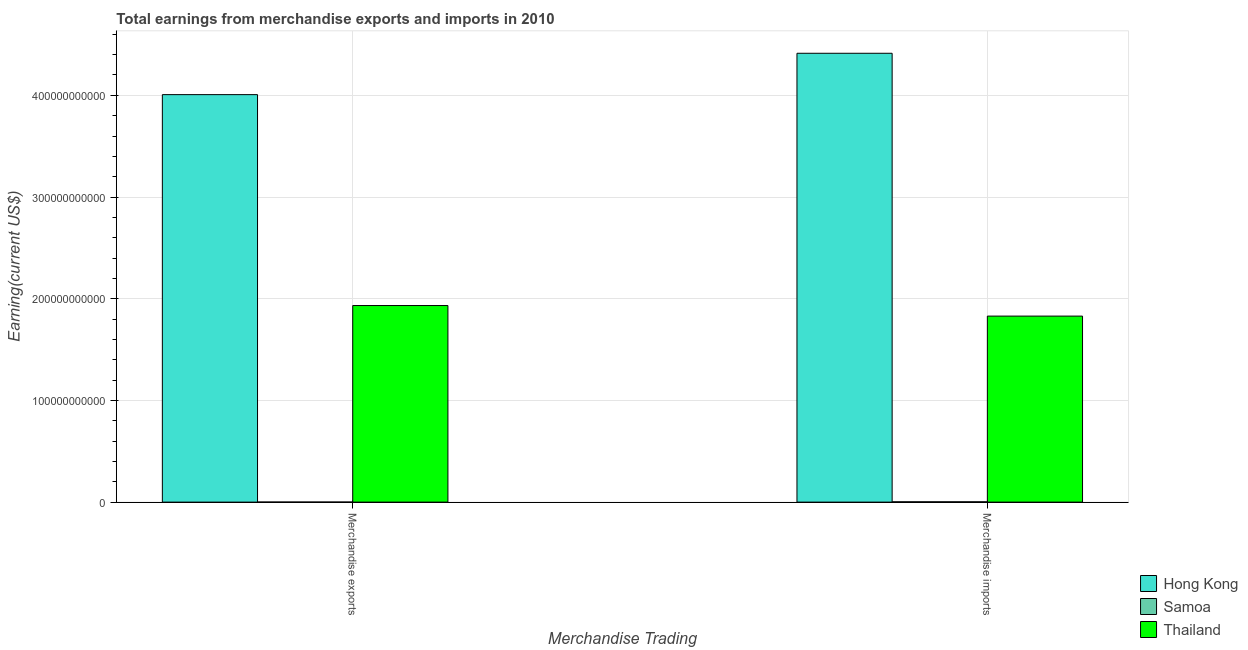Are the number of bars per tick equal to the number of legend labels?
Offer a terse response. Yes. How many bars are there on the 1st tick from the left?
Ensure brevity in your answer.  3. What is the label of the 1st group of bars from the left?
Offer a terse response. Merchandise exports. What is the earnings from merchandise exports in Thailand?
Keep it short and to the point. 1.93e+11. Across all countries, what is the maximum earnings from merchandise imports?
Your answer should be very brief. 4.41e+11. Across all countries, what is the minimum earnings from merchandise imports?
Ensure brevity in your answer.  3.10e+08. In which country was the earnings from merchandise imports maximum?
Your answer should be very brief. Hong Kong. In which country was the earnings from merchandise imports minimum?
Keep it short and to the point. Samoa. What is the total earnings from merchandise exports in the graph?
Keep it short and to the point. 5.94e+11. What is the difference between the earnings from merchandise imports in Thailand and that in Samoa?
Your response must be concise. 1.83e+11. What is the difference between the earnings from merchandise exports in Thailand and the earnings from merchandise imports in Hong Kong?
Ensure brevity in your answer.  -2.48e+11. What is the average earnings from merchandise exports per country?
Ensure brevity in your answer.  1.98e+11. What is the difference between the earnings from merchandise imports and earnings from merchandise exports in Thailand?
Keep it short and to the point. -1.04e+1. In how many countries, is the earnings from merchandise imports greater than 280000000000 US$?
Your response must be concise. 1. What is the ratio of the earnings from merchandise imports in Samoa to that in Hong Kong?
Offer a terse response. 0. In how many countries, is the earnings from merchandise imports greater than the average earnings from merchandise imports taken over all countries?
Your answer should be compact. 1. What does the 1st bar from the left in Merchandise imports represents?
Ensure brevity in your answer.  Hong Kong. What does the 2nd bar from the right in Merchandise imports represents?
Keep it short and to the point. Samoa. How many bars are there?
Provide a short and direct response. 6. Are all the bars in the graph horizontal?
Your response must be concise. No. What is the difference between two consecutive major ticks on the Y-axis?
Your answer should be very brief. 1.00e+11. How many legend labels are there?
Ensure brevity in your answer.  3. What is the title of the graph?
Give a very brief answer. Total earnings from merchandise exports and imports in 2010. Does "Guam" appear as one of the legend labels in the graph?
Provide a succinct answer. No. What is the label or title of the X-axis?
Ensure brevity in your answer.  Merchandise Trading. What is the label or title of the Y-axis?
Ensure brevity in your answer.  Earning(current US$). What is the Earning(current US$) in Hong Kong in Merchandise exports?
Your response must be concise. 4.01e+11. What is the Earning(current US$) in Samoa in Merchandise exports?
Make the answer very short. 7.02e+07. What is the Earning(current US$) in Thailand in Merchandise exports?
Your answer should be compact. 1.93e+11. What is the Earning(current US$) of Hong Kong in Merchandise imports?
Ensure brevity in your answer.  4.41e+11. What is the Earning(current US$) of Samoa in Merchandise imports?
Give a very brief answer. 3.10e+08. What is the Earning(current US$) of Thailand in Merchandise imports?
Your response must be concise. 1.83e+11. Across all Merchandise Trading, what is the maximum Earning(current US$) of Hong Kong?
Provide a succinct answer. 4.41e+11. Across all Merchandise Trading, what is the maximum Earning(current US$) of Samoa?
Make the answer very short. 3.10e+08. Across all Merchandise Trading, what is the maximum Earning(current US$) in Thailand?
Offer a terse response. 1.93e+11. Across all Merchandise Trading, what is the minimum Earning(current US$) in Hong Kong?
Your answer should be very brief. 4.01e+11. Across all Merchandise Trading, what is the minimum Earning(current US$) in Samoa?
Your answer should be compact. 7.02e+07. Across all Merchandise Trading, what is the minimum Earning(current US$) of Thailand?
Ensure brevity in your answer.  1.83e+11. What is the total Earning(current US$) of Hong Kong in the graph?
Keep it short and to the point. 8.42e+11. What is the total Earning(current US$) in Samoa in the graph?
Your response must be concise. 3.80e+08. What is the total Earning(current US$) of Thailand in the graph?
Offer a terse response. 3.76e+11. What is the difference between the Earning(current US$) in Hong Kong in Merchandise exports and that in Merchandise imports?
Keep it short and to the point. -4.07e+1. What is the difference between the Earning(current US$) in Samoa in Merchandise exports and that in Merchandise imports?
Make the answer very short. -2.40e+08. What is the difference between the Earning(current US$) in Thailand in Merchandise exports and that in Merchandise imports?
Give a very brief answer. 1.04e+1. What is the difference between the Earning(current US$) in Hong Kong in Merchandise exports and the Earning(current US$) in Samoa in Merchandise imports?
Your response must be concise. 4.00e+11. What is the difference between the Earning(current US$) of Hong Kong in Merchandise exports and the Earning(current US$) of Thailand in Merchandise imports?
Give a very brief answer. 2.18e+11. What is the difference between the Earning(current US$) of Samoa in Merchandise exports and the Earning(current US$) of Thailand in Merchandise imports?
Ensure brevity in your answer.  -1.83e+11. What is the average Earning(current US$) of Hong Kong per Merchandise Trading?
Your response must be concise. 4.21e+11. What is the average Earning(current US$) of Samoa per Merchandise Trading?
Keep it short and to the point. 1.90e+08. What is the average Earning(current US$) of Thailand per Merchandise Trading?
Give a very brief answer. 1.88e+11. What is the difference between the Earning(current US$) in Hong Kong and Earning(current US$) in Samoa in Merchandise exports?
Your answer should be very brief. 4.01e+11. What is the difference between the Earning(current US$) of Hong Kong and Earning(current US$) of Thailand in Merchandise exports?
Offer a terse response. 2.07e+11. What is the difference between the Earning(current US$) of Samoa and Earning(current US$) of Thailand in Merchandise exports?
Offer a terse response. -1.93e+11. What is the difference between the Earning(current US$) in Hong Kong and Earning(current US$) in Samoa in Merchandise imports?
Make the answer very short. 4.41e+11. What is the difference between the Earning(current US$) of Hong Kong and Earning(current US$) of Thailand in Merchandise imports?
Make the answer very short. 2.58e+11. What is the difference between the Earning(current US$) of Samoa and Earning(current US$) of Thailand in Merchandise imports?
Your response must be concise. -1.83e+11. What is the ratio of the Earning(current US$) in Hong Kong in Merchandise exports to that in Merchandise imports?
Keep it short and to the point. 0.91. What is the ratio of the Earning(current US$) of Samoa in Merchandise exports to that in Merchandise imports?
Offer a very short reply. 0.23. What is the ratio of the Earning(current US$) of Thailand in Merchandise exports to that in Merchandise imports?
Your response must be concise. 1.06. What is the difference between the highest and the second highest Earning(current US$) in Hong Kong?
Provide a succinct answer. 4.07e+1. What is the difference between the highest and the second highest Earning(current US$) of Samoa?
Give a very brief answer. 2.40e+08. What is the difference between the highest and the second highest Earning(current US$) of Thailand?
Provide a short and direct response. 1.04e+1. What is the difference between the highest and the lowest Earning(current US$) of Hong Kong?
Ensure brevity in your answer.  4.07e+1. What is the difference between the highest and the lowest Earning(current US$) in Samoa?
Your answer should be compact. 2.40e+08. What is the difference between the highest and the lowest Earning(current US$) of Thailand?
Make the answer very short. 1.04e+1. 